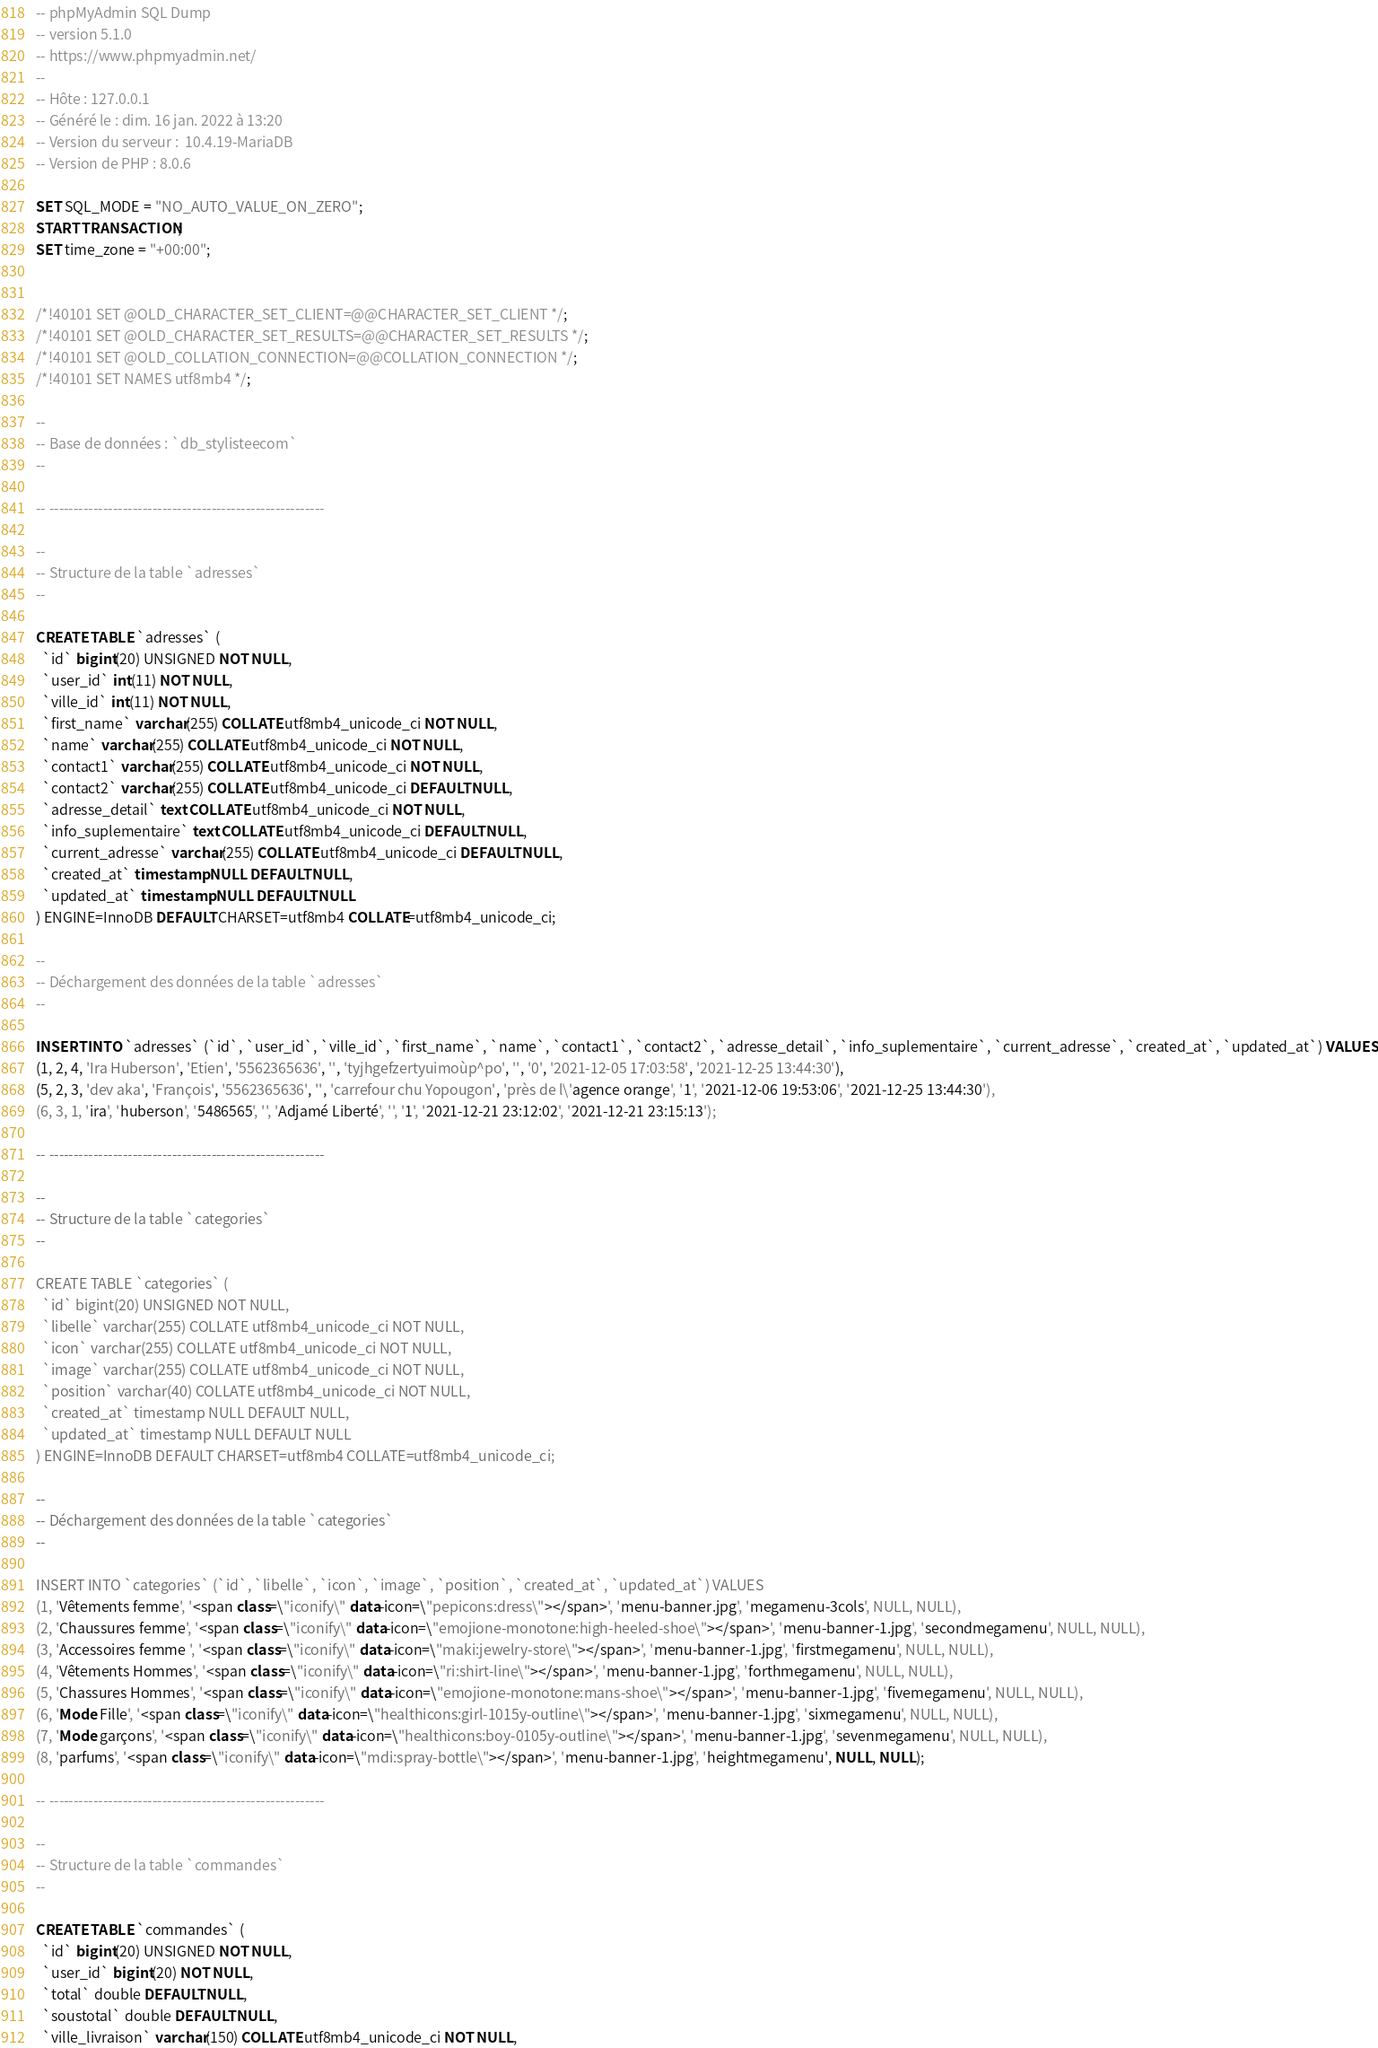Convert code to text. <code><loc_0><loc_0><loc_500><loc_500><_SQL_>-- phpMyAdmin SQL Dump
-- version 5.1.0
-- https://www.phpmyadmin.net/
--
-- Hôte : 127.0.0.1
-- Généré le : dim. 16 jan. 2022 à 13:20
-- Version du serveur :  10.4.19-MariaDB
-- Version de PHP : 8.0.6

SET SQL_MODE = "NO_AUTO_VALUE_ON_ZERO";
START TRANSACTION;
SET time_zone = "+00:00";


/*!40101 SET @OLD_CHARACTER_SET_CLIENT=@@CHARACTER_SET_CLIENT */;
/*!40101 SET @OLD_CHARACTER_SET_RESULTS=@@CHARACTER_SET_RESULTS */;
/*!40101 SET @OLD_COLLATION_CONNECTION=@@COLLATION_CONNECTION */;
/*!40101 SET NAMES utf8mb4 */;

--
-- Base de données : `db_stylisteecom`
--

-- --------------------------------------------------------

--
-- Structure de la table `adresses`
--

CREATE TABLE `adresses` (
  `id` bigint(20) UNSIGNED NOT NULL,
  `user_id` int(11) NOT NULL,
  `ville_id` int(11) NOT NULL,
  `first_name` varchar(255) COLLATE utf8mb4_unicode_ci NOT NULL,
  `name` varchar(255) COLLATE utf8mb4_unicode_ci NOT NULL,
  `contact1` varchar(255) COLLATE utf8mb4_unicode_ci NOT NULL,
  `contact2` varchar(255) COLLATE utf8mb4_unicode_ci DEFAULT NULL,
  `adresse_detail` text COLLATE utf8mb4_unicode_ci NOT NULL,
  `info_suplementaire` text COLLATE utf8mb4_unicode_ci DEFAULT NULL,
  `current_adresse` varchar(255) COLLATE utf8mb4_unicode_ci DEFAULT NULL,
  `created_at` timestamp NULL DEFAULT NULL,
  `updated_at` timestamp NULL DEFAULT NULL
) ENGINE=InnoDB DEFAULT CHARSET=utf8mb4 COLLATE=utf8mb4_unicode_ci;

--
-- Déchargement des données de la table `adresses`
--

INSERT INTO `adresses` (`id`, `user_id`, `ville_id`, `first_name`, `name`, `contact1`, `contact2`, `adresse_detail`, `info_suplementaire`, `current_adresse`, `created_at`, `updated_at`) VALUES
(1, 2, 4, 'Ira Huberson', 'Etien', '5562365636', '', 'tyjhgefzertyuimoùp^po', '', '0', '2021-12-05 17:03:58', '2021-12-25 13:44:30'),
(5, 2, 3, 'dev aka', 'François', '5562365636', '', 'carrefour chu Yopougon', 'près de l\'agence orange', '1', '2021-12-06 19:53:06', '2021-12-25 13:44:30'),
(6, 3, 1, 'ira', 'huberson', '5486565', '', 'Adjamé Liberté', '', '1', '2021-12-21 23:12:02', '2021-12-21 23:15:13');

-- --------------------------------------------------------

--
-- Structure de la table `categories`
--

CREATE TABLE `categories` (
  `id` bigint(20) UNSIGNED NOT NULL,
  `libelle` varchar(255) COLLATE utf8mb4_unicode_ci NOT NULL,
  `icon` varchar(255) COLLATE utf8mb4_unicode_ci NOT NULL,
  `image` varchar(255) COLLATE utf8mb4_unicode_ci NOT NULL,
  `position` varchar(40) COLLATE utf8mb4_unicode_ci NOT NULL,
  `created_at` timestamp NULL DEFAULT NULL,
  `updated_at` timestamp NULL DEFAULT NULL
) ENGINE=InnoDB DEFAULT CHARSET=utf8mb4 COLLATE=utf8mb4_unicode_ci;

--
-- Déchargement des données de la table `categories`
--

INSERT INTO `categories` (`id`, `libelle`, `icon`, `image`, `position`, `created_at`, `updated_at`) VALUES
(1, 'Vêtements femme', '<span class=\"iconify\" data-icon=\"pepicons:dress\"></span>', 'menu-banner.jpg', 'megamenu-3cols', NULL, NULL),
(2, 'Chaussures femme', '<span class=\"iconify\" data-icon=\"emojione-monotone:high-heeled-shoe\"></span>', 'menu-banner-1.jpg', 'secondmegamenu', NULL, NULL),
(3, 'Accessoires femme ', '<span class=\"iconify\" data-icon=\"maki:jewelry-store\"></span>', 'menu-banner-1.jpg', 'firstmegamenu', NULL, NULL),
(4, 'Vêtements Hommes', '<span class=\"iconify\" data-icon=\"ri:shirt-line\"></span>', 'menu-banner-1.jpg', 'forthmegamenu', NULL, NULL),
(5, 'Chassures Hommes', '<span class=\"iconify\" data-icon=\"emojione-monotone:mans-shoe\"></span>', 'menu-banner-1.jpg', 'fivemegamenu', NULL, NULL),
(6, 'Mode Fille', '<span class=\"iconify\" data-icon=\"healthicons:girl-1015y-outline\"></span>', 'menu-banner-1.jpg', 'sixmegamenu', NULL, NULL),
(7, 'Mode garçons', '<span class=\"iconify\" data-icon=\"healthicons:boy-0105y-outline\"></span>', 'menu-banner-1.jpg', 'sevenmegamenu', NULL, NULL),
(8, 'parfums', '<span class=\"iconify\" data-icon=\"mdi:spray-bottle\"></span>', 'menu-banner-1.jpg', 'heightmegamenu', NULL, NULL);

-- --------------------------------------------------------

--
-- Structure de la table `commandes`
--

CREATE TABLE `commandes` (
  `id` bigint(20) UNSIGNED NOT NULL,
  `user_id` bigint(20) NOT NULL,
  `total` double DEFAULT NULL,
  `soustotal` double DEFAULT NULL,
  `ville_livraison` varchar(150) COLLATE utf8mb4_unicode_ci NOT NULL,</code> 